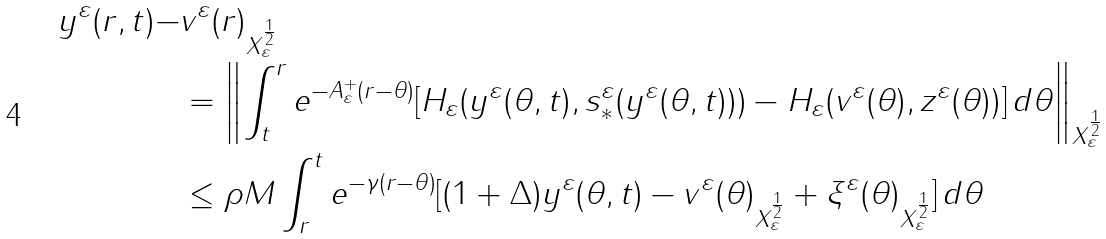Convert formula to latex. <formula><loc_0><loc_0><loc_500><loc_500>\| y ^ { \varepsilon } ( r , t ) - & v ^ { \varepsilon } ( r ) \| _ { X _ { \varepsilon } ^ { \frac { 1 } { 2 } } } \\ & = \left \| \int _ { t } ^ { r } e ^ { - A _ { \varepsilon } ^ { + } ( r - \theta ) } [ H _ { \varepsilon } ( y ^ { \varepsilon } ( \theta , t ) , s _ { * } ^ { \varepsilon } ( y ^ { \varepsilon } ( \theta , t ) ) ) - H _ { \varepsilon } ( v ^ { \varepsilon } ( \theta ) , z ^ { \varepsilon } ( \theta ) ) ] \, d \theta \right \| _ { X _ { \varepsilon } ^ { \frac { 1 } { 2 } } } \\ & \leq \rho M \int _ { r } ^ { t } e ^ { - \gamma ( r - \theta ) } [ ( 1 + \Delta ) \| y ^ { \varepsilon } ( \theta , t ) - v ^ { \varepsilon } ( \theta ) \| _ { X _ { \varepsilon } ^ { \frac { 1 } { 2 } } } + \| \xi ^ { \varepsilon } ( \theta ) \| _ { X _ { \varepsilon } ^ { \frac { 1 } { 2 } } } ] \, d \theta</formula> 